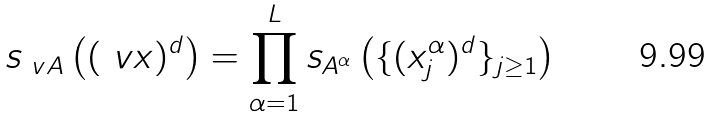Convert formula to latex. <formula><loc_0><loc_0><loc_500><loc_500>s _ { \ v A } \left ( ( \ v x ) ^ { d } \right ) = \prod _ { \alpha = 1 } ^ { L } s _ { A ^ { \alpha } } \left ( \{ ( x ^ { \alpha } _ { j } ) ^ { d } \} _ { j \geq 1 } \right )</formula> 